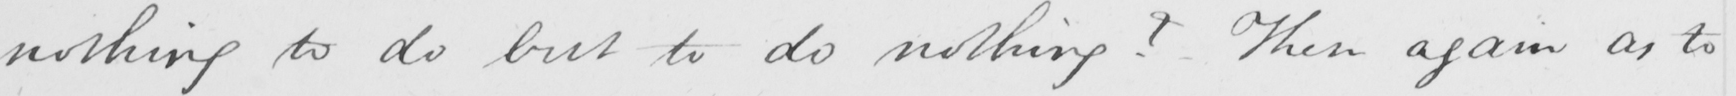Please provide the text content of this handwritten line. nothing to do but to do nothing ?  - Then again as to 